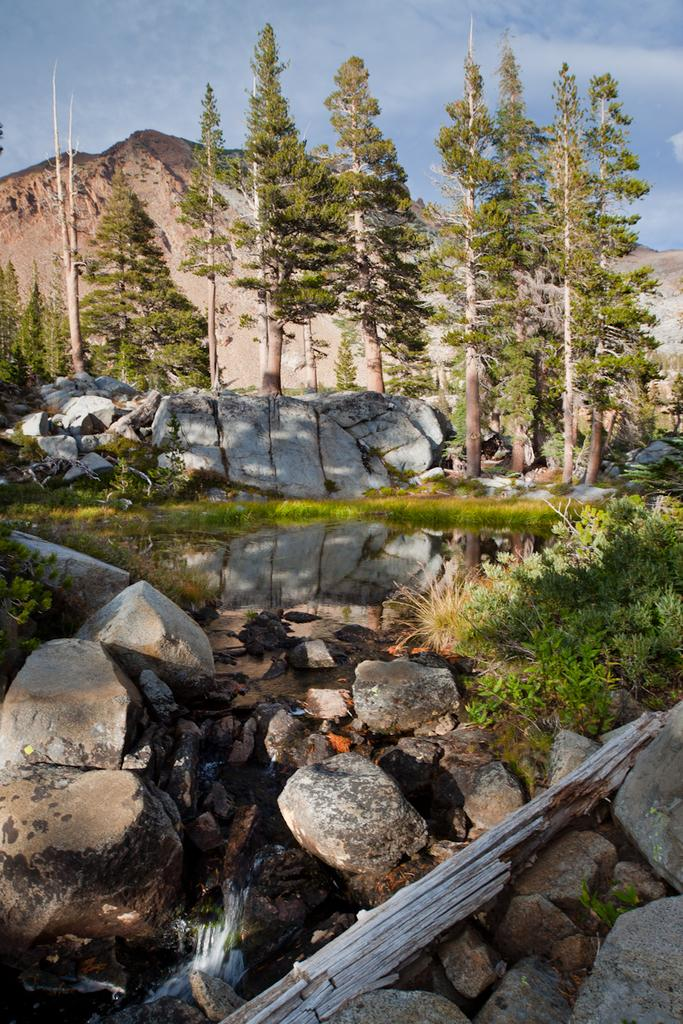What type of body of water is present in the image? There is a pond in the image. What other natural elements can be seen in the image? There are rocks and trees visible in the image. What is the landscape feature in the background of the image? There are mountains in the background of the image. What is the condition of the sky in the image? The sky is clear in the image. Where is the swing located in the image? There is no swing present in the image. What type of cemetery can be seen in the image? There is no cemetery present in the image. 